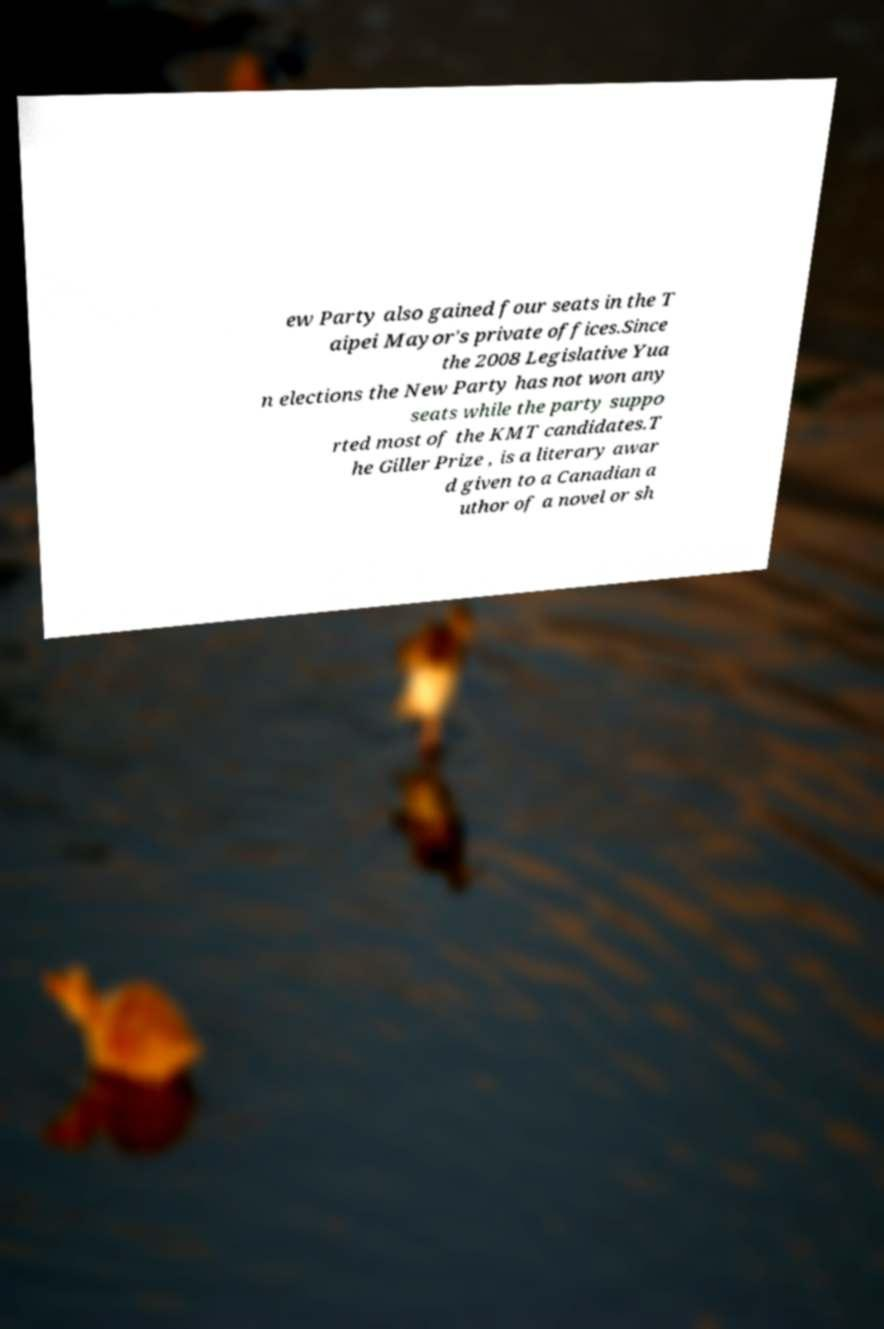There's text embedded in this image that I need extracted. Can you transcribe it verbatim? ew Party also gained four seats in the T aipei Mayor's private offices.Since the 2008 Legislative Yua n elections the New Party has not won any seats while the party suppo rted most of the KMT candidates.T he Giller Prize , is a literary awar d given to a Canadian a uthor of a novel or sh 